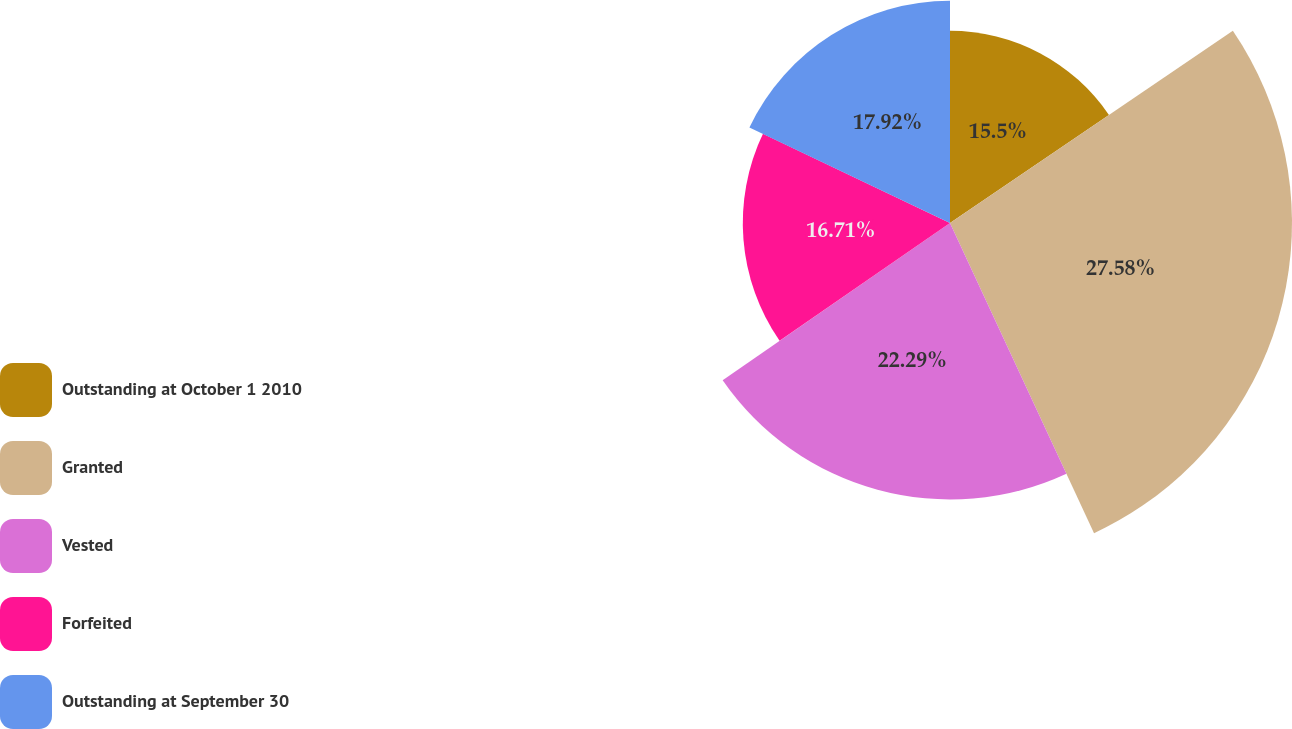<chart> <loc_0><loc_0><loc_500><loc_500><pie_chart><fcel>Outstanding at October 1 2010<fcel>Granted<fcel>Vested<fcel>Forfeited<fcel>Outstanding at September 30<nl><fcel>15.5%<fcel>27.58%<fcel>22.29%<fcel>16.71%<fcel>17.92%<nl></chart> 